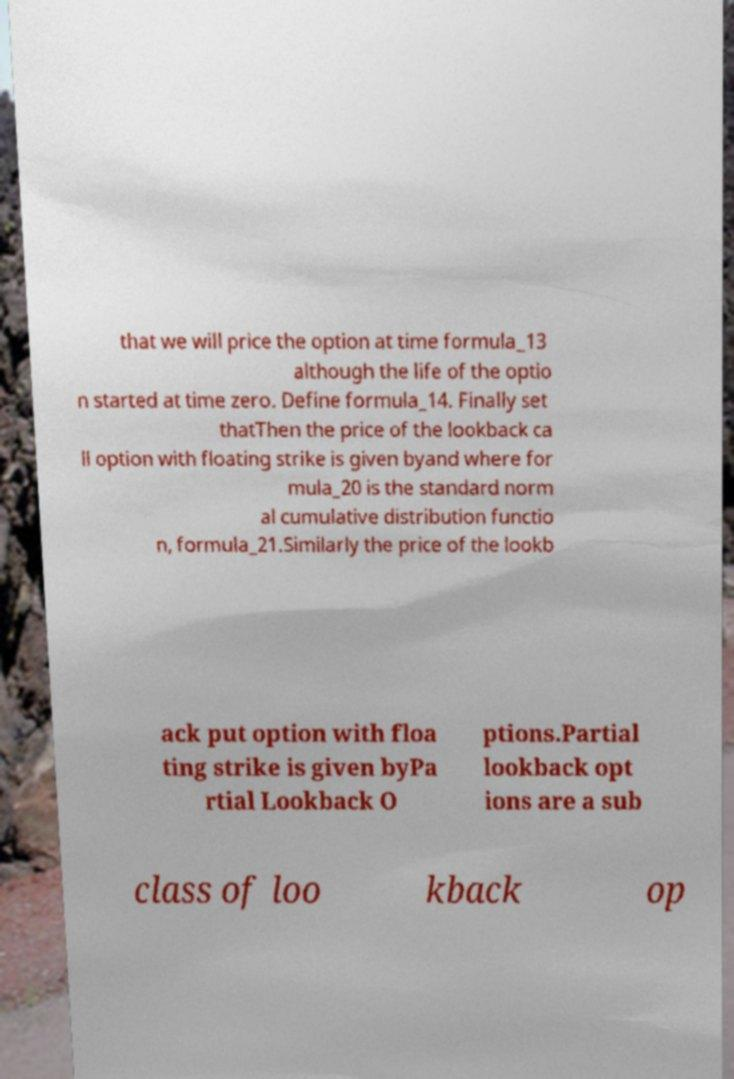For documentation purposes, I need the text within this image transcribed. Could you provide that? that we will price the option at time formula_13 although the life of the optio n started at time zero. Define formula_14. Finally set thatThen the price of the lookback ca ll option with floating strike is given byand where for mula_20 is the standard norm al cumulative distribution functio n, formula_21.Similarly the price of the lookb ack put option with floa ting strike is given byPa rtial Lookback O ptions.Partial lookback opt ions are a sub class of loo kback op 